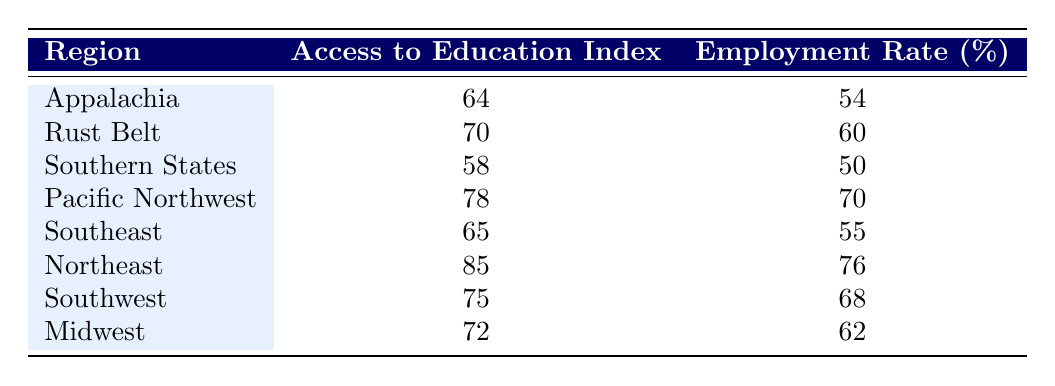What is the access to education index for the Northeast region? The table shows that the access to education index for the Northeast region is listed directly under the corresponding column. It clearly shows the value as 85.
Answer: 85 Which region has the highest employment rate? By looking through the employment rate column, we identify that the Northeast region has the highest value at 76, making it the region with the highest employment rate.
Answer: Northeast What is the difference in employment rates between the Pacific Northwest and the Southern States? The employment rate for the Pacific Northwest is 70 and for the Southern States, it is 50. To find the difference, we calculate 70 - 50 = 20.
Answer: 20 Is the access to education index for the Rust Belt higher than that for the Southern States? The access to education index for Rust Belt is 70, while it is 58 for Southern States. Since 70 is greater than 58, this statement is true.
Answer: Yes What is the average access to education index across all regions? To find the average access to education index, we add all the individual indices: (64 + 70 + 58 + 78 + 65 + 85 + 75 + 72) = 564. Since there are 8 data points, we divide 564 by 8, resulting in an average of 70.5.
Answer: 70.5 Which region demonstrates a better employment rate relative to its access to education index: Southeast or Southwest? The Southeast has an employment rate of 55 and an access to education index of 65, giving a ratio of 55/65 = 0.846. The Southwest has an employment rate of 68 with an index of 75, giving a ratio of 68/75 = 0.907. Since 0.907 is higher, the Southwest performs better in terms of employment rate relative to its index.
Answer: Southwest How many regions have an access to education index above 70? By reviewing the access to education index column, we see that the regions with indices above 70 are the Rust Belt (70), Pacific Northwest (78), Northeast (85), and Southwest (75). Thus, there are 4 regions above this threshold.
Answer: 4 Which region shows a decreased employment rate and access to education index compared to the Northeast? The Northeast has an access to education index of 85 and an employment rate of 76. The region that shows lower values for both criteria is Appalachia, which has an index of 64 and an employment rate of 54. Thus, Appalachia is the answer.
Answer: Appalachia 